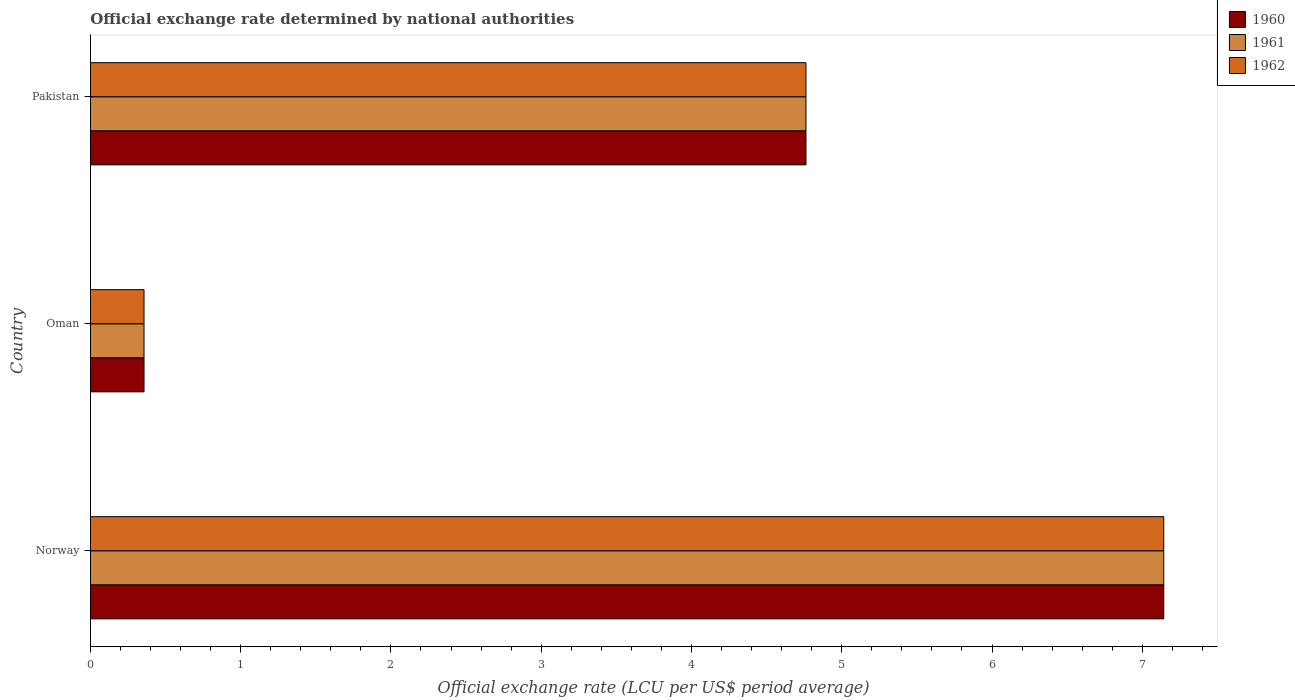How many groups of bars are there?
Make the answer very short. 3. Are the number of bars per tick equal to the number of legend labels?
Your answer should be compact. Yes. How many bars are there on the 2nd tick from the bottom?
Your answer should be very brief. 3. What is the label of the 1st group of bars from the top?
Offer a very short reply. Pakistan. In how many cases, is the number of bars for a given country not equal to the number of legend labels?
Provide a succinct answer. 0. What is the official exchange rate in 1961 in Norway?
Offer a terse response. 7.14. Across all countries, what is the maximum official exchange rate in 1962?
Provide a succinct answer. 7.14. Across all countries, what is the minimum official exchange rate in 1961?
Your answer should be compact. 0.36. In which country was the official exchange rate in 1960 maximum?
Keep it short and to the point. Norway. In which country was the official exchange rate in 1960 minimum?
Offer a terse response. Oman. What is the total official exchange rate in 1961 in the graph?
Offer a very short reply. 12.26. What is the difference between the official exchange rate in 1960 in Norway and that in Oman?
Keep it short and to the point. 6.79. What is the difference between the official exchange rate in 1962 in Pakistan and the official exchange rate in 1961 in Oman?
Give a very brief answer. 4.4. What is the average official exchange rate in 1962 per country?
Provide a succinct answer. 4.09. What is the ratio of the official exchange rate in 1961 in Norway to that in Oman?
Offer a very short reply. 20. Is the difference between the official exchange rate in 1962 in Norway and Pakistan greater than the difference between the official exchange rate in 1960 in Norway and Pakistan?
Provide a succinct answer. No. What is the difference between the highest and the second highest official exchange rate in 1960?
Provide a short and direct response. 2.38. What is the difference between the highest and the lowest official exchange rate in 1961?
Make the answer very short. 6.79. What does the 2nd bar from the bottom in Norway represents?
Your answer should be very brief. 1961. Is it the case that in every country, the sum of the official exchange rate in 1962 and official exchange rate in 1960 is greater than the official exchange rate in 1961?
Keep it short and to the point. Yes. How many bars are there?
Ensure brevity in your answer.  9. What is the difference between two consecutive major ticks on the X-axis?
Ensure brevity in your answer.  1. Are the values on the major ticks of X-axis written in scientific E-notation?
Offer a terse response. No. Does the graph contain grids?
Keep it short and to the point. No. How many legend labels are there?
Keep it short and to the point. 3. How are the legend labels stacked?
Keep it short and to the point. Vertical. What is the title of the graph?
Provide a short and direct response. Official exchange rate determined by national authorities. What is the label or title of the X-axis?
Ensure brevity in your answer.  Official exchange rate (LCU per US$ period average). What is the label or title of the Y-axis?
Give a very brief answer. Country. What is the Official exchange rate (LCU per US$ period average) in 1960 in Norway?
Keep it short and to the point. 7.14. What is the Official exchange rate (LCU per US$ period average) of 1961 in Norway?
Provide a short and direct response. 7.14. What is the Official exchange rate (LCU per US$ period average) of 1962 in Norway?
Provide a short and direct response. 7.14. What is the Official exchange rate (LCU per US$ period average) of 1960 in Oman?
Your answer should be very brief. 0.36. What is the Official exchange rate (LCU per US$ period average) of 1961 in Oman?
Offer a very short reply. 0.36. What is the Official exchange rate (LCU per US$ period average) of 1962 in Oman?
Your response must be concise. 0.36. What is the Official exchange rate (LCU per US$ period average) of 1960 in Pakistan?
Give a very brief answer. 4.76. What is the Official exchange rate (LCU per US$ period average) of 1961 in Pakistan?
Give a very brief answer. 4.76. What is the Official exchange rate (LCU per US$ period average) in 1962 in Pakistan?
Your response must be concise. 4.76. Across all countries, what is the maximum Official exchange rate (LCU per US$ period average) of 1960?
Your answer should be very brief. 7.14. Across all countries, what is the maximum Official exchange rate (LCU per US$ period average) of 1961?
Your response must be concise. 7.14. Across all countries, what is the maximum Official exchange rate (LCU per US$ period average) of 1962?
Offer a terse response. 7.14. Across all countries, what is the minimum Official exchange rate (LCU per US$ period average) of 1960?
Provide a succinct answer. 0.36. Across all countries, what is the minimum Official exchange rate (LCU per US$ period average) in 1961?
Keep it short and to the point. 0.36. Across all countries, what is the minimum Official exchange rate (LCU per US$ period average) in 1962?
Your answer should be compact. 0.36. What is the total Official exchange rate (LCU per US$ period average) in 1960 in the graph?
Give a very brief answer. 12.26. What is the total Official exchange rate (LCU per US$ period average) in 1961 in the graph?
Ensure brevity in your answer.  12.26. What is the total Official exchange rate (LCU per US$ period average) in 1962 in the graph?
Offer a very short reply. 12.26. What is the difference between the Official exchange rate (LCU per US$ period average) of 1960 in Norway and that in Oman?
Give a very brief answer. 6.79. What is the difference between the Official exchange rate (LCU per US$ period average) of 1961 in Norway and that in Oman?
Provide a short and direct response. 6.79. What is the difference between the Official exchange rate (LCU per US$ period average) in 1962 in Norway and that in Oman?
Give a very brief answer. 6.79. What is the difference between the Official exchange rate (LCU per US$ period average) of 1960 in Norway and that in Pakistan?
Offer a very short reply. 2.38. What is the difference between the Official exchange rate (LCU per US$ period average) in 1961 in Norway and that in Pakistan?
Your answer should be compact. 2.38. What is the difference between the Official exchange rate (LCU per US$ period average) in 1962 in Norway and that in Pakistan?
Ensure brevity in your answer.  2.38. What is the difference between the Official exchange rate (LCU per US$ period average) of 1960 in Oman and that in Pakistan?
Offer a terse response. -4.4. What is the difference between the Official exchange rate (LCU per US$ period average) of 1961 in Oman and that in Pakistan?
Your response must be concise. -4.4. What is the difference between the Official exchange rate (LCU per US$ period average) in 1962 in Oman and that in Pakistan?
Offer a terse response. -4.4. What is the difference between the Official exchange rate (LCU per US$ period average) of 1960 in Norway and the Official exchange rate (LCU per US$ period average) of 1961 in Oman?
Offer a terse response. 6.79. What is the difference between the Official exchange rate (LCU per US$ period average) in 1960 in Norway and the Official exchange rate (LCU per US$ period average) in 1962 in Oman?
Keep it short and to the point. 6.79. What is the difference between the Official exchange rate (LCU per US$ period average) in 1961 in Norway and the Official exchange rate (LCU per US$ period average) in 1962 in Oman?
Provide a short and direct response. 6.79. What is the difference between the Official exchange rate (LCU per US$ period average) of 1960 in Norway and the Official exchange rate (LCU per US$ period average) of 1961 in Pakistan?
Provide a short and direct response. 2.38. What is the difference between the Official exchange rate (LCU per US$ period average) of 1960 in Norway and the Official exchange rate (LCU per US$ period average) of 1962 in Pakistan?
Keep it short and to the point. 2.38. What is the difference between the Official exchange rate (LCU per US$ period average) of 1961 in Norway and the Official exchange rate (LCU per US$ period average) of 1962 in Pakistan?
Ensure brevity in your answer.  2.38. What is the difference between the Official exchange rate (LCU per US$ period average) of 1960 in Oman and the Official exchange rate (LCU per US$ period average) of 1961 in Pakistan?
Offer a terse response. -4.4. What is the difference between the Official exchange rate (LCU per US$ period average) of 1960 in Oman and the Official exchange rate (LCU per US$ period average) of 1962 in Pakistan?
Provide a short and direct response. -4.4. What is the difference between the Official exchange rate (LCU per US$ period average) in 1961 in Oman and the Official exchange rate (LCU per US$ period average) in 1962 in Pakistan?
Your response must be concise. -4.4. What is the average Official exchange rate (LCU per US$ period average) of 1960 per country?
Provide a short and direct response. 4.09. What is the average Official exchange rate (LCU per US$ period average) in 1961 per country?
Provide a succinct answer. 4.09. What is the average Official exchange rate (LCU per US$ period average) in 1962 per country?
Provide a short and direct response. 4.09. What is the difference between the Official exchange rate (LCU per US$ period average) of 1960 and Official exchange rate (LCU per US$ period average) of 1961 in Norway?
Offer a very short reply. 0. What is the difference between the Official exchange rate (LCU per US$ period average) in 1960 and Official exchange rate (LCU per US$ period average) in 1961 in Oman?
Your answer should be very brief. 0. What is the difference between the Official exchange rate (LCU per US$ period average) in 1960 and Official exchange rate (LCU per US$ period average) in 1962 in Oman?
Provide a short and direct response. 0. What is the difference between the Official exchange rate (LCU per US$ period average) in 1961 and Official exchange rate (LCU per US$ period average) in 1962 in Oman?
Make the answer very short. 0. What is the difference between the Official exchange rate (LCU per US$ period average) in 1960 and Official exchange rate (LCU per US$ period average) in 1961 in Pakistan?
Offer a very short reply. 0. What is the difference between the Official exchange rate (LCU per US$ period average) of 1960 and Official exchange rate (LCU per US$ period average) of 1962 in Pakistan?
Your answer should be compact. 0. What is the difference between the Official exchange rate (LCU per US$ period average) in 1961 and Official exchange rate (LCU per US$ period average) in 1962 in Pakistan?
Make the answer very short. 0. What is the ratio of the Official exchange rate (LCU per US$ period average) of 1962 in Norway to that in Oman?
Ensure brevity in your answer.  20. What is the ratio of the Official exchange rate (LCU per US$ period average) of 1960 in Norway to that in Pakistan?
Keep it short and to the point. 1.5. What is the ratio of the Official exchange rate (LCU per US$ period average) in 1962 in Norway to that in Pakistan?
Ensure brevity in your answer.  1.5. What is the ratio of the Official exchange rate (LCU per US$ period average) in 1960 in Oman to that in Pakistan?
Offer a very short reply. 0.07. What is the ratio of the Official exchange rate (LCU per US$ period average) of 1961 in Oman to that in Pakistan?
Your answer should be very brief. 0.07. What is the ratio of the Official exchange rate (LCU per US$ period average) in 1962 in Oman to that in Pakistan?
Your response must be concise. 0.07. What is the difference between the highest and the second highest Official exchange rate (LCU per US$ period average) of 1960?
Your answer should be very brief. 2.38. What is the difference between the highest and the second highest Official exchange rate (LCU per US$ period average) of 1961?
Ensure brevity in your answer.  2.38. What is the difference between the highest and the second highest Official exchange rate (LCU per US$ period average) of 1962?
Make the answer very short. 2.38. What is the difference between the highest and the lowest Official exchange rate (LCU per US$ period average) of 1960?
Give a very brief answer. 6.79. What is the difference between the highest and the lowest Official exchange rate (LCU per US$ period average) in 1961?
Your response must be concise. 6.79. What is the difference between the highest and the lowest Official exchange rate (LCU per US$ period average) in 1962?
Your answer should be compact. 6.79. 